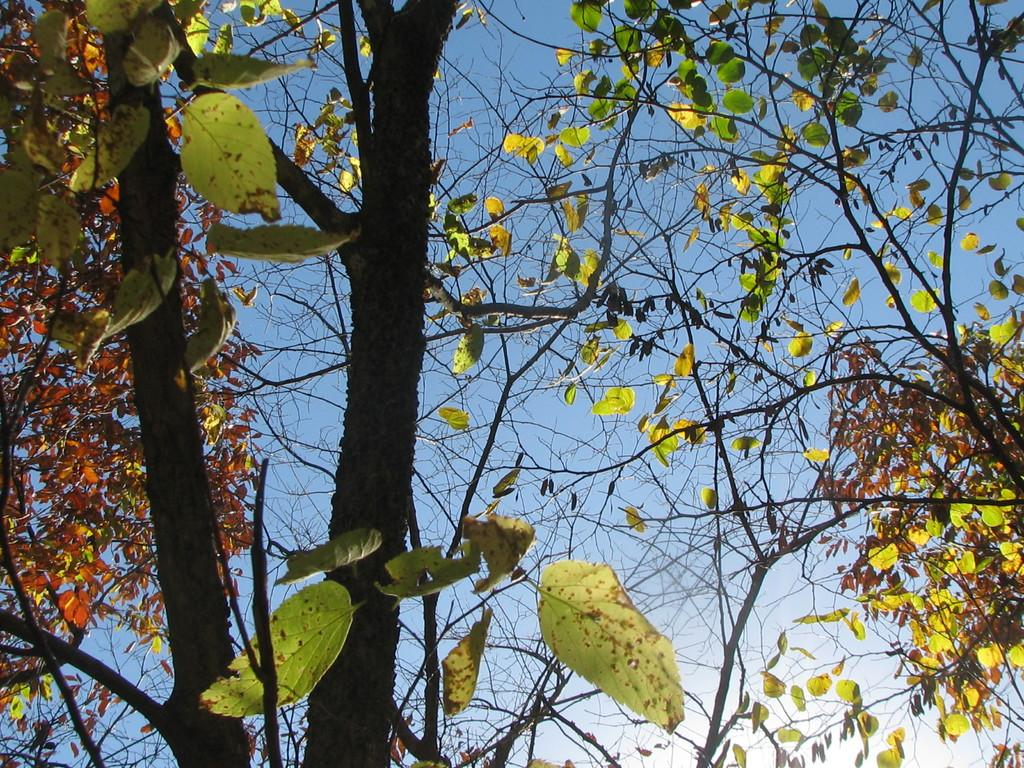What type of vegetation can be seen in the image? There are trees in the image. How would you describe the condition of the leaves on the trees? The trees have dry and green leaves. What can be seen in the background of the image? The sky is visible in the background of the image. What is the color of the sky in the image? The sky is blue in color. How does the sink look in the image? There is no sink present in the image. What is the purpose of the trees in the image? The purpose of the trees in the image is not explicitly stated, but they are likely part of the natural landscape. 